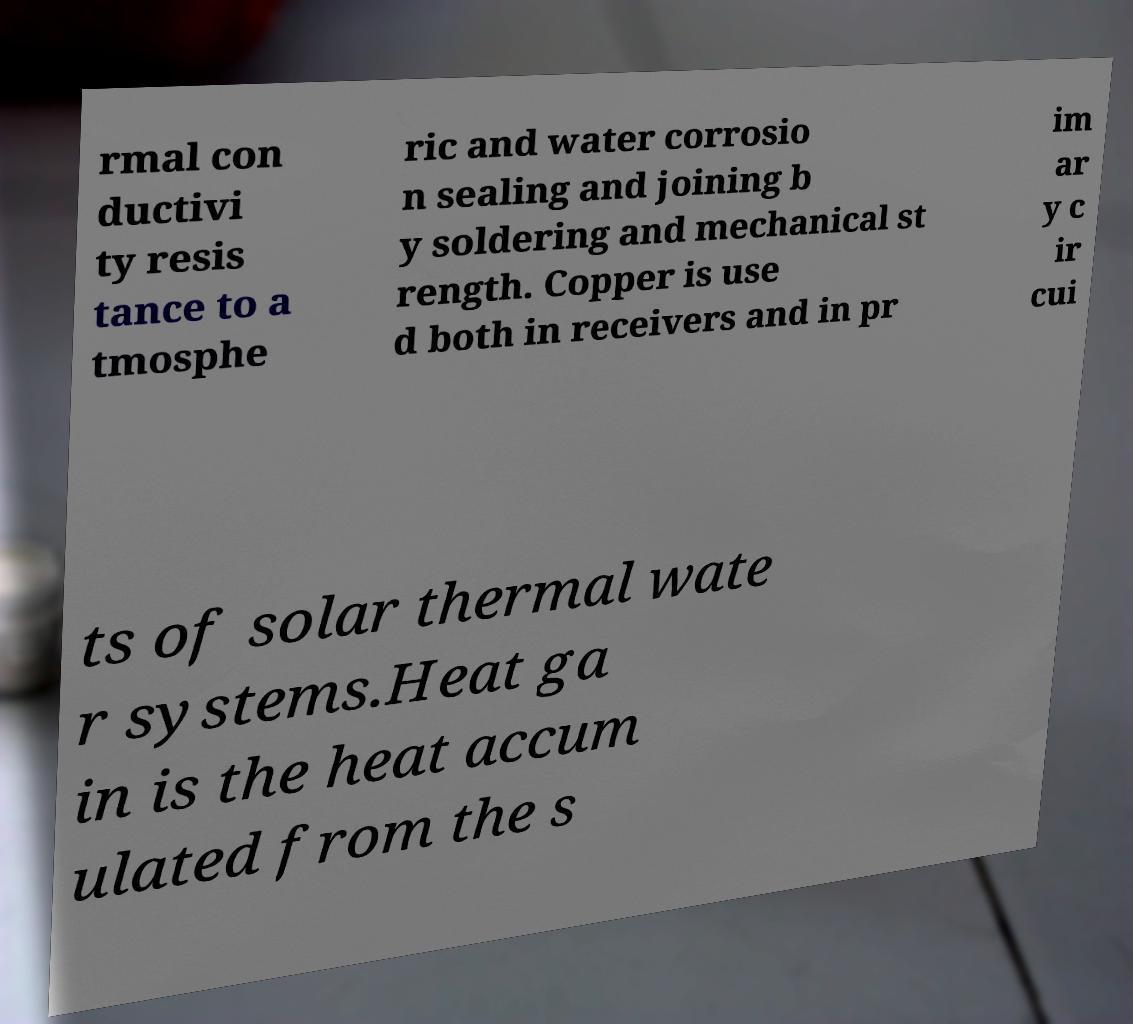Please identify and transcribe the text found in this image. rmal con ductivi ty resis tance to a tmosphe ric and water corrosio n sealing and joining b y soldering and mechanical st rength. Copper is use d both in receivers and in pr im ar y c ir cui ts of solar thermal wate r systems.Heat ga in is the heat accum ulated from the s 